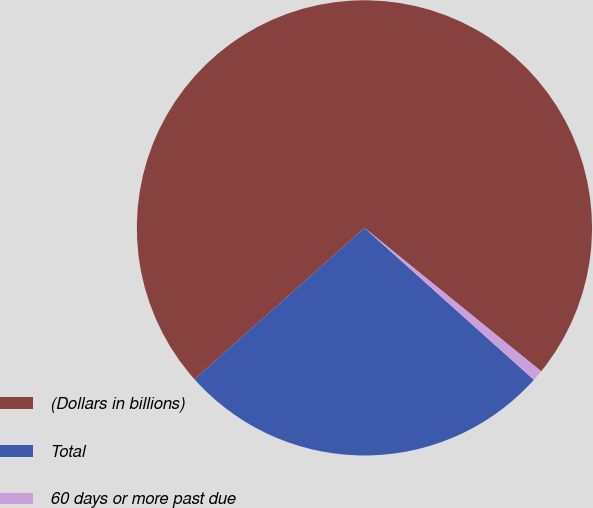<chart> <loc_0><loc_0><loc_500><loc_500><pie_chart><fcel>(Dollars in billions)<fcel>Total<fcel>60 days or more past due<nl><fcel>72.43%<fcel>26.78%<fcel>0.79%<nl></chart> 